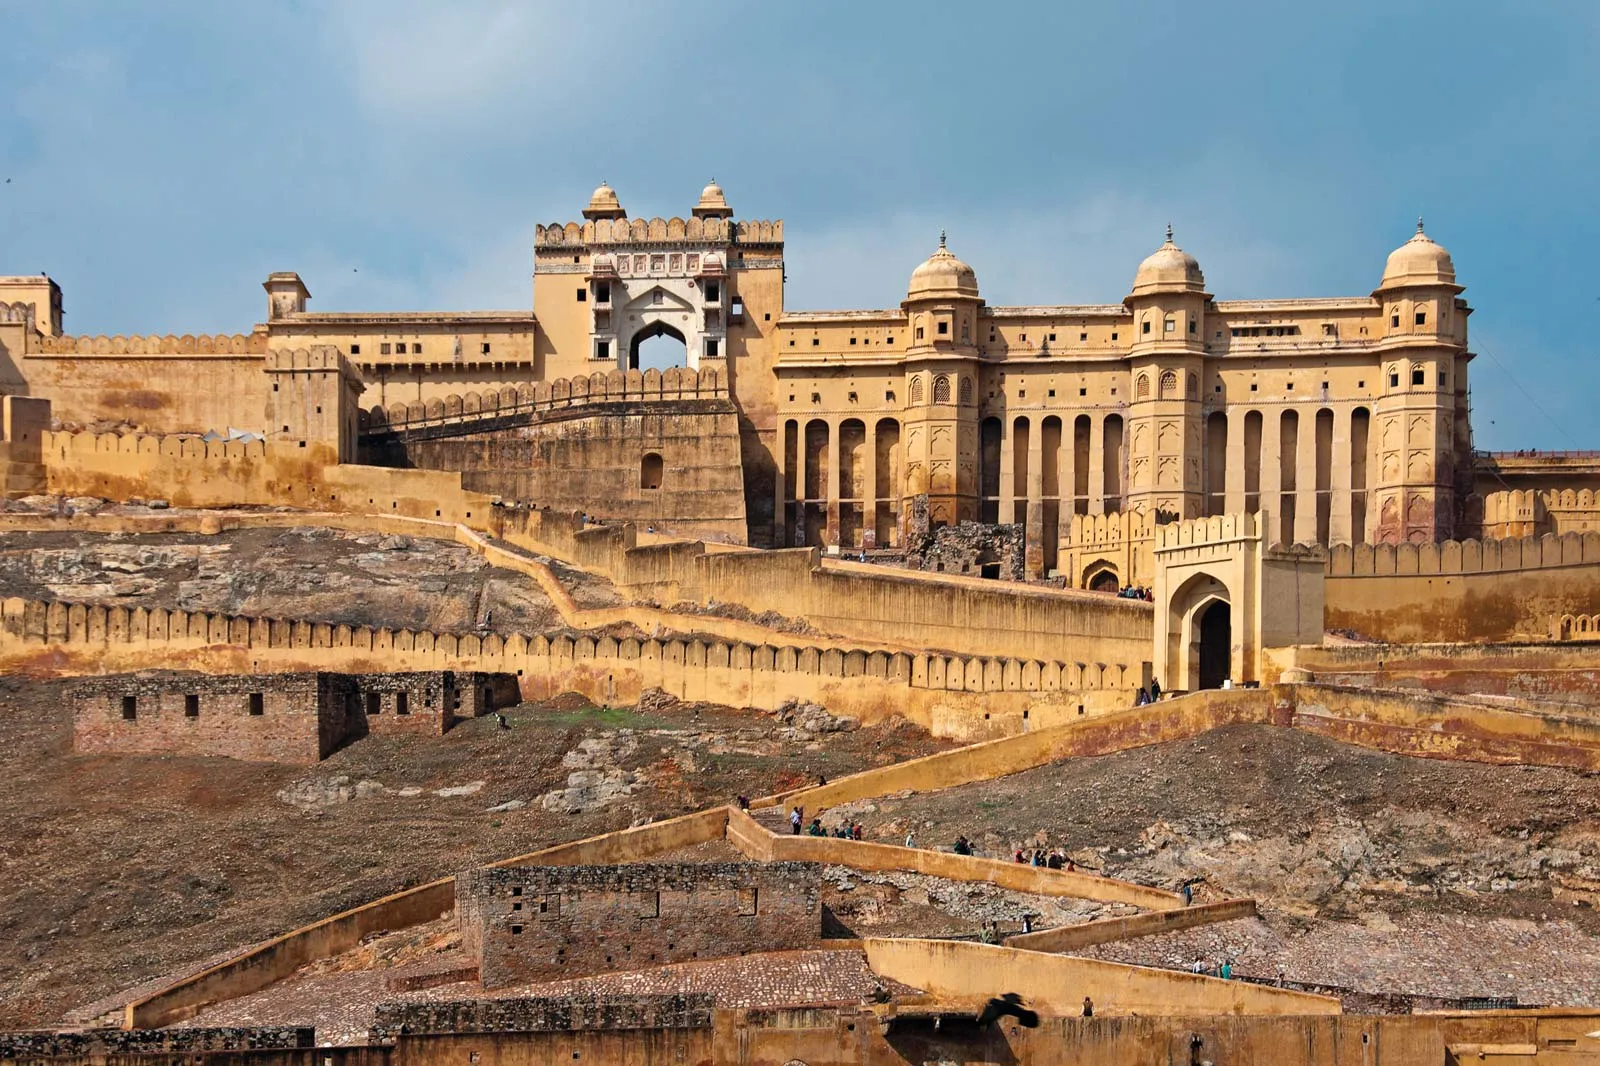What do you see happening in this image? The image showcases the majestic Amber Fort, a historical fortification located in Rajasthan, India. It is constructed from yellow sandstone and features intricate architectural details that highlight the craftsmanship of the era. The fort spans across multiple levels and is perched on a hill, offering a panoramic view of its surroundings. The photograph captures the fort’s grandeur from a lower perspective, emphasizing its imposing structure. The background includes a clear blue sky with scattered clouds, adding a serene contrast to the historic monument. 